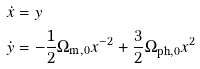<formula> <loc_0><loc_0><loc_500><loc_500>\dot { x } & = y \\ \dot { y } & = - \frac { 1 } { 2 } \Omega _ { \text {m} , 0 } x ^ { - 2 } + \frac { 3 } { 2 } \Omega _ { \text {ph} , 0 } x ^ { 2 }</formula> 